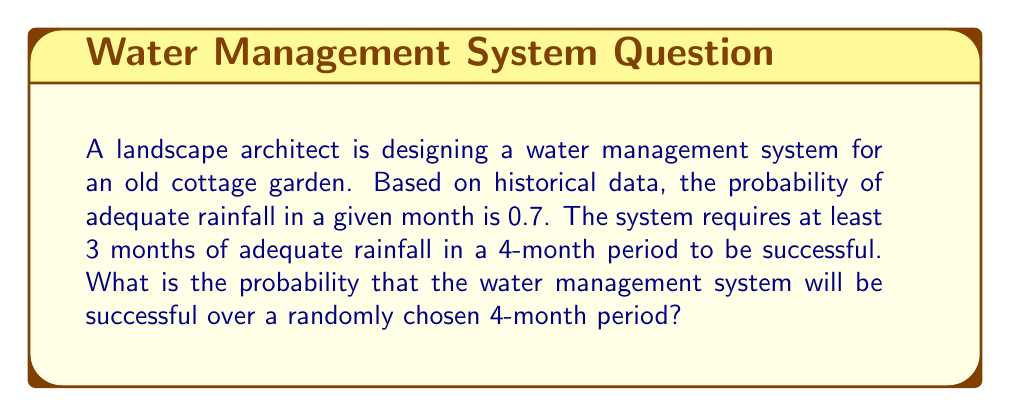Provide a solution to this math problem. Let's approach this step-by-step using the binomial probability distribution:

1) We can model this as a binomial experiment where:
   n = 4 (number of months)
   p = 0.7 (probability of adequate rainfall in a month)
   q = 1 - p = 0.3 (probability of inadequate rainfall in a month)

2) The system is successful if there are 3 or 4 months of adequate rainfall.

3) We need to calculate P(X ≥ 3), where X is the number of months with adequate rainfall.

4) P(X ≥ 3) = P(X = 3) + P(X = 4)

5) Using the binomial probability formula:
   $$P(X = k) = \binom{n}{k} p^k q^{n-k}$$

6) For P(X = 3):
   $$P(X = 3) = \binom{4}{3} (0.7)^3 (0.3)^1 = 4 \cdot 0.343 \cdot 0.3 = 0.4116$$

7) For P(X = 4):
   $$P(X = 4) = \binom{4}{4} (0.7)^4 (0.3)^0 = 1 \cdot 0.2401 \cdot 1 = 0.2401$$

8) Therefore, the probability of success is:
   P(X ≥ 3) = P(X = 3) + P(X = 4) = 0.4116 + 0.2401 = 0.6517
Answer: 0.6517 